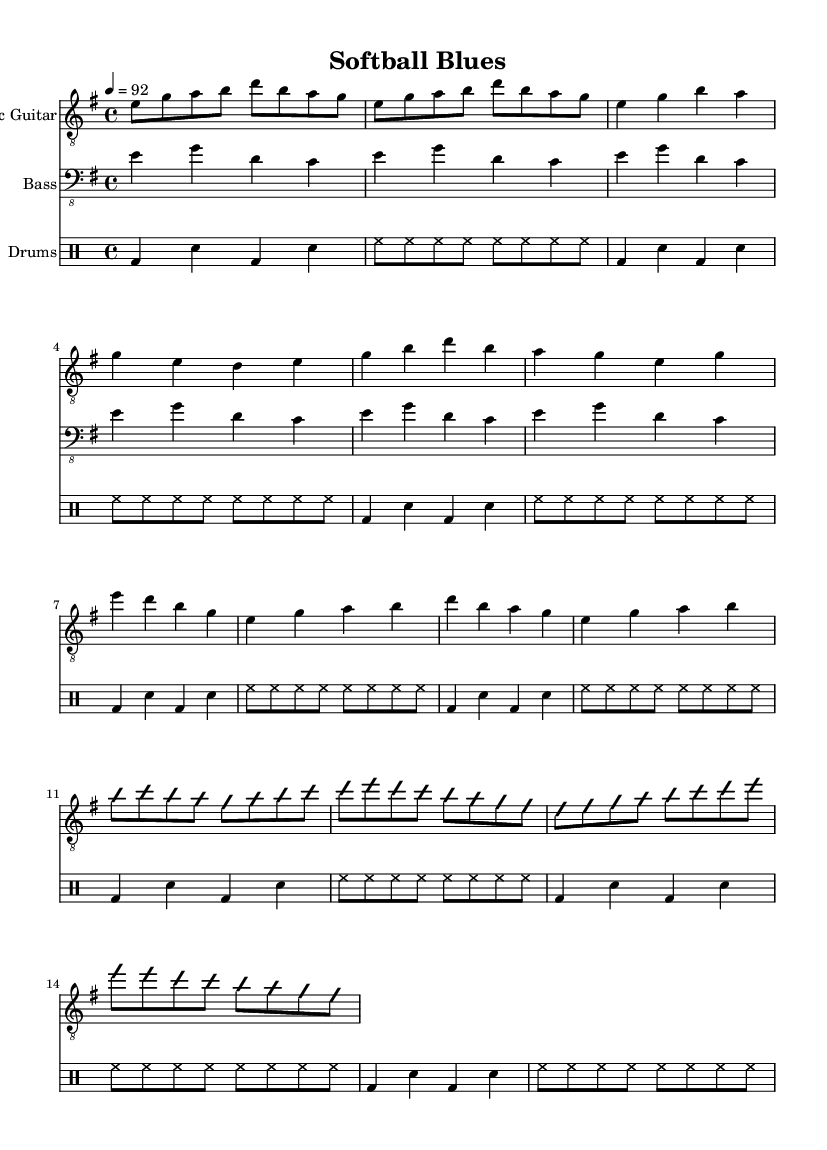What is the key signature of this music? The key signature for this piece is E minor, as indicated by the key signature at the beginning of the score showing one sharp (F#).
Answer: E minor What is the time signature of this music? The time signature is 4/4, as indicated at the beginning of the score. This means there are four beats in each measure and the quarter note gets one beat.
Answer: 4/4 What is the tempo marking of this music? The tempo marking is 4 = 92, which indicates a quarter note should be played at a speed of 92 beats per minute.
Answer: 92 How many measures are there in the verse? The verse consists of four measures, as counted from the music notation provided in the verse section.
Answer: 4 Describe the main character of the melody used in the chorus. The melody in the chorus prominently features descending and ascending movements, with a mixture of 4th and 5th intervals that create a bittersweet texture typical of electric blues.
Answer: Descending and ascending movements What instrument features an improvisation section? The electric guitar features an improvisation section, as indicated by the "improvisationOn" and "improvisationOff" markings in the score.
Answer: Electric guitar Identify a musical element characteristic of electric blues present in this piece. The presence of a distinct guitar riff, which serves as both an introduction and a musical theme, is characteristic of electric blues, highlighting expressive melodic lines often seen in this genre.
Answer: Guitar riff 